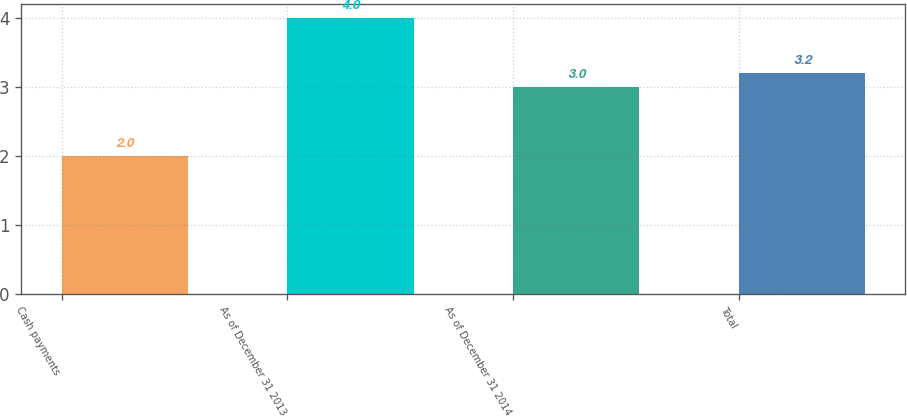Convert chart to OTSL. <chart><loc_0><loc_0><loc_500><loc_500><bar_chart><fcel>Cash payments<fcel>As of December 31 2013<fcel>As of December 31 2014<fcel>Total<nl><fcel>2<fcel>4<fcel>3<fcel>3.2<nl></chart> 